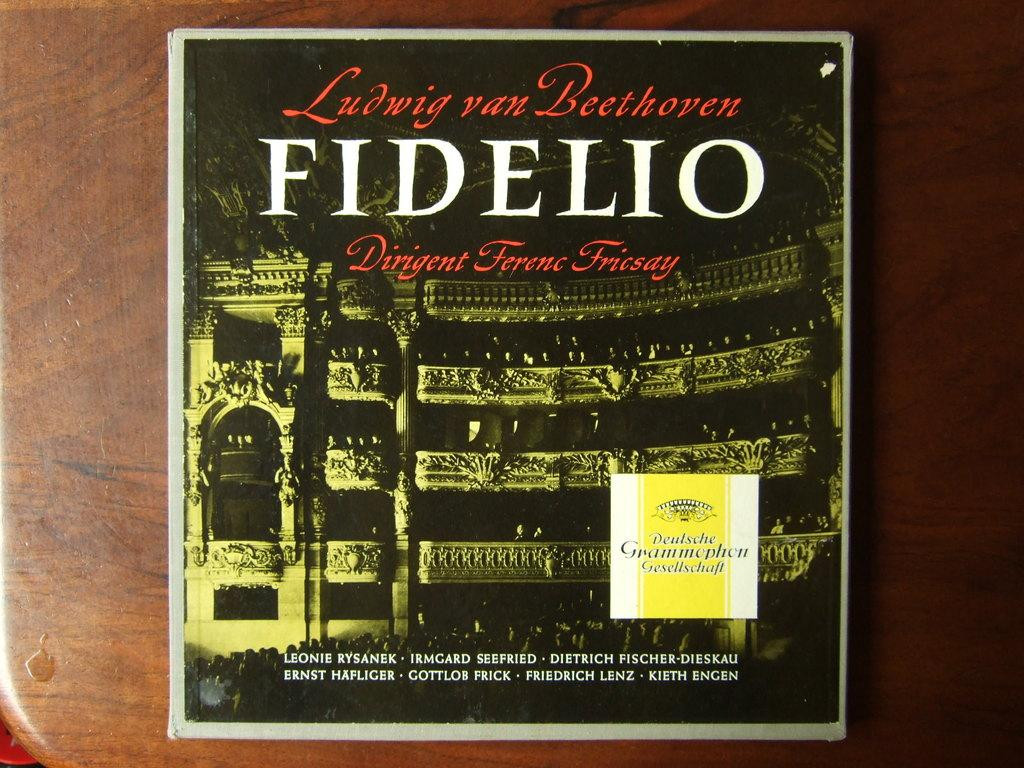<image>
Provide a brief description of the given image. the name Fidelip that is on a cover 